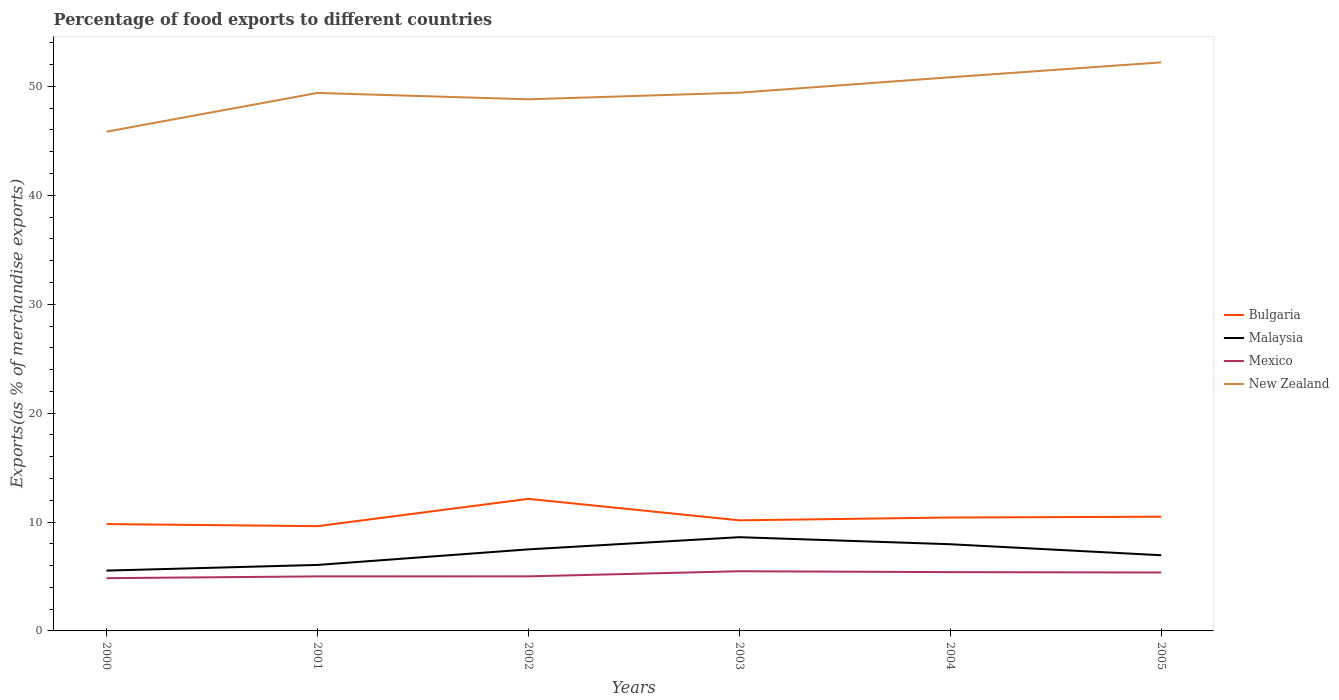How many different coloured lines are there?
Keep it short and to the point. 4. Is the number of lines equal to the number of legend labels?
Make the answer very short. Yes. Across all years, what is the maximum percentage of exports to different countries in Bulgaria?
Provide a succinct answer. 9.62. In which year was the percentage of exports to different countries in Malaysia maximum?
Give a very brief answer. 2000. What is the total percentage of exports to different countries in Mexico in the graph?
Make the answer very short. -0.47. What is the difference between the highest and the second highest percentage of exports to different countries in New Zealand?
Give a very brief answer. 6.37. Is the percentage of exports to different countries in Malaysia strictly greater than the percentage of exports to different countries in Mexico over the years?
Give a very brief answer. No. How many lines are there?
Your answer should be compact. 4. How many years are there in the graph?
Offer a very short reply. 6. Are the values on the major ticks of Y-axis written in scientific E-notation?
Offer a very short reply. No. Does the graph contain any zero values?
Your answer should be very brief. No. Does the graph contain grids?
Your answer should be very brief. No. Where does the legend appear in the graph?
Ensure brevity in your answer.  Center right. How are the legend labels stacked?
Make the answer very short. Vertical. What is the title of the graph?
Offer a terse response. Percentage of food exports to different countries. What is the label or title of the X-axis?
Make the answer very short. Years. What is the label or title of the Y-axis?
Ensure brevity in your answer.  Exports(as % of merchandise exports). What is the Exports(as % of merchandise exports) in Bulgaria in 2000?
Provide a short and direct response. 9.81. What is the Exports(as % of merchandise exports) of Malaysia in 2000?
Your response must be concise. 5.54. What is the Exports(as % of merchandise exports) of Mexico in 2000?
Your response must be concise. 4.84. What is the Exports(as % of merchandise exports) in New Zealand in 2000?
Your answer should be compact. 45.84. What is the Exports(as % of merchandise exports) of Bulgaria in 2001?
Ensure brevity in your answer.  9.62. What is the Exports(as % of merchandise exports) in Malaysia in 2001?
Provide a short and direct response. 6.06. What is the Exports(as % of merchandise exports) of Mexico in 2001?
Keep it short and to the point. 5.01. What is the Exports(as % of merchandise exports) in New Zealand in 2001?
Your answer should be very brief. 49.4. What is the Exports(as % of merchandise exports) of Bulgaria in 2002?
Provide a succinct answer. 12.13. What is the Exports(as % of merchandise exports) in Malaysia in 2002?
Provide a short and direct response. 7.49. What is the Exports(as % of merchandise exports) of Mexico in 2002?
Make the answer very short. 5.01. What is the Exports(as % of merchandise exports) in New Zealand in 2002?
Provide a succinct answer. 48.82. What is the Exports(as % of merchandise exports) of Bulgaria in 2003?
Your response must be concise. 10.16. What is the Exports(as % of merchandise exports) of Malaysia in 2003?
Your answer should be compact. 8.61. What is the Exports(as % of merchandise exports) in Mexico in 2003?
Offer a very short reply. 5.48. What is the Exports(as % of merchandise exports) of New Zealand in 2003?
Your answer should be very brief. 49.42. What is the Exports(as % of merchandise exports) of Bulgaria in 2004?
Offer a terse response. 10.41. What is the Exports(as % of merchandise exports) of Malaysia in 2004?
Provide a short and direct response. 7.96. What is the Exports(as % of merchandise exports) of Mexico in 2004?
Keep it short and to the point. 5.4. What is the Exports(as % of merchandise exports) of New Zealand in 2004?
Your response must be concise. 50.84. What is the Exports(as % of merchandise exports) of Bulgaria in 2005?
Your answer should be compact. 10.49. What is the Exports(as % of merchandise exports) of Malaysia in 2005?
Keep it short and to the point. 6.95. What is the Exports(as % of merchandise exports) of Mexico in 2005?
Your response must be concise. 5.37. What is the Exports(as % of merchandise exports) in New Zealand in 2005?
Provide a short and direct response. 52.21. Across all years, what is the maximum Exports(as % of merchandise exports) of Bulgaria?
Your answer should be very brief. 12.13. Across all years, what is the maximum Exports(as % of merchandise exports) of Malaysia?
Offer a terse response. 8.61. Across all years, what is the maximum Exports(as % of merchandise exports) of Mexico?
Offer a terse response. 5.48. Across all years, what is the maximum Exports(as % of merchandise exports) in New Zealand?
Provide a short and direct response. 52.21. Across all years, what is the minimum Exports(as % of merchandise exports) in Bulgaria?
Your answer should be compact. 9.62. Across all years, what is the minimum Exports(as % of merchandise exports) in Malaysia?
Your answer should be very brief. 5.54. Across all years, what is the minimum Exports(as % of merchandise exports) in Mexico?
Ensure brevity in your answer.  4.84. Across all years, what is the minimum Exports(as % of merchandise exports) of New Zealand?
Your response must be concise. 45.84. What is the total Exports(as % of merchandise exports) in Bulgaria in the graph?
Provide a short and direct response. 62.62. What is the total Exports(as % of merchandise exports) in Malaysia in the graph?
Offer a very short reply. 42.61. What is the total Exports(as % of merchandise exports) of Mexico in the graph?
Keep it short and to the point. 31.1. What is the total Exports(as % of merchandise exports) in New Zealand in the graph?
Ensure brevity in your answer.  296.54. What is the difference between the Exports(as % of merchandise exports) of Bulgaria in 2000 and that in 2001?
Offer a very short reply. 0.19. What is the difference between the Exports(as % of merchandise exports) of Malaysia in 2000 and that in 2001?
Ensure brevity in your answer.  -0.52. What is the difference between the Exports(as % of merchandise exports) in Mexico in 2000 and that in 2001?
Your answer should be compact. -0.16. What is the difference between the Exports(as % of merchandise exports) in New Zealand in 2000 and that in 2001?
Ensure brevity in your answer.  -3.56. What is the difference between the Exports(as % of merchandise exports) of Bulgaria in 2000 and that in 2002?
Ensure brevity in your answer.  -2.32. What is the difference between the Exports(as % of merchandise exports) of Malaysia in 2000 and that in 2002?
Offer a very short reply. -1.95. What is the difference between the Exports(as % of merchandise exports) of Mexico in 2000 and that in 2002?
Provide a succinct answer. -0.17. What is the difference between the Exports(as % of merchandise exports) in New Zealand in 2000 and that in 2002?
Provide a succinct answer. -2.98. What is the difference between the Exports(as % of merchandise exports) of Bulgaria in 2000 and that in 2003?
Keep it short and to the point. -0.34. What is the difference between the Exports(as % of merchandise exports) of Malaysia in 2000 and that in 2003?
Your response must be concise. -3.07. What is the difference between the Exports(as % of merchandise exports) of Mexico in 2000 and that in 2003?
Offer a terse response. -0.64. What is the difference between the Exports(as % of merchandise exports) of New Zealand in 2000 and that in 2003?
Give a very brief answer. -3.58. What is the difference between the Exports(as % of merchandise exports) of Bulgaria in 2000 and that in 2004?
Offer a very short reply. -0.6. What is the difference between the Exports(as % of merchandise exports) of Malaysia in 2000 and that in 2004?
Offer a very short reply. -2.42. What is the difference between the Exports(as % of merchandise exports) in Mexico in 2000 and that in 2004?
Offer a very short reply. -0.56. What is the difference between the Exports(as % of merchandise exports) in New Zealand in 2000 and that in 2004?
Your answer should be very brief. -5. What is the difference between the Exports(as % of merchandise exports) in Bulgaria in 2000 and that in 2005?
Provide a succinct answer. -0.68. What is the difference between the Exports(as % of merchandise exports) in Malaysia in 2000 and that in 2005?
Your answer should be compact. -1.41. What is the difference between the Exports(as % of merchandise exports) of Mexico in 2000 and that in 2005?
Give a very brief answer. -0.52. What is the difference between the Exports(as % of merchandise exports) in New Zealand in 2000 and that in 2005?
Provide a short and direct response. -6.37. What is the difference between the Exports(as % of merchandise exports) of Bulgaria in 2001 and that in 2002?
Provide a short and direct response. -2.51. What is the difference between the Exports(as % of merchandise exports) of Malaysia in 2001 and that in 2002?
Keep it short and to the point. -1.43. What is the difference between the Exports(as % of merchandise exports) of Mexico in 2001 and that in 2002?
Offer a terse response. -0. What is the difference between the Exports(as % of merchandise exports) of New Zealand in 2001 and that in 2002?
Give a very brief answer. 0.58. What is the difference between the Exports(as % of merchandise exports) of Bulgaria in 2001 and that in 2003?
Give a very brief answer. -0.53. What is the difference between the Exports(as % of merchandise exports) in Malaysia in 2001 and that in 2003?
Make the answer very short. -2.55. What is the difference between the Exports(as % of merchandise exports) in Mexico in 2001 and that in 2003?
Your answer should be compact. -0.47. What is the difference between the Exports(as % of merchandise exports) of New Zealand in 2001 and that in 2003?
Provide a short and direct response. -0.02. What is the difference between the Exports(as % of merchandise exports) in Bulgaria in 2001 and that in 2004?
Make the answer very short. -0.79. What is the difference between the Exports(as % of merchandise exports) in Malaysia in 2001 and that in 2004?
Your answer should be very brief. -1.9. What is the difference between the Exports(as % of merchandise exports) in Mexico in 2001 and that in 2004?
Your answer should be compact. -0.39. What is the difference between the Exports(as % of merchandise exports) in New Zealand in 2001 and that in 2004?
Your answer should be compact. -1.44. What is the difference between the Exports(as % of merchandise exports) of Bulgaria in 2001 and that in 2005?
Your answer should be compact. -0.87. What is the difference between the Exports(as % of merchandise exports) in Malaysia in 2001 and that in 2005?
Your response must be concise. -0.89. What is the difference between the Exports(as % of merchandise exports) of Mexico in 2001 and that in 2005?
Ensure brevity in your answer.  -0.36. What is the difference between the Exports(as % of merchandise exports) of New Zealand in 2001 and that in 2005?
Ensure brevity in your answer.  -2.81. What is the difference between the Exports(as % of merchandise exports) of Bulgaria in 2002 and that in 2003?
Provide a succinct answer. 1.97. What is the difference between the Exports(as % of merchandise exports) in Malaysia in 2002 and that in 2003?
Your response must be concise. -1.12. What is the difference between the Exports(as % of merchandise exports) of Mexico in 2002 and that in 2003?
Offer a very short reply. -0.47. What is the difference between the Exports(as % of merchandise exports) in New Zealand in 2002 and that in 2003?
Offer a terse response. -0.61. What is the difference between the Exports(as % of merchandise exports) in Bulgaria in 2002 and that in 2004?
Offer a terse response. 1.71. What is the difference between the Exports(as % of merchandise exports) in Malaysia in 2002 and that in 2004?
Your answer should be compact. -0.47. What is the difference between the Exports(as % of merchandise exports) in Mexico in 2002 and that in 2004?
Ensure brevity in your answer.  -0.39. What is the difference between the Exports(as % of merchandise exports) in New Zealand in 2002 and that in 2004?
Your answer should be compact. -2.02. What is the difference between the Exports(as % of merchandise exports) of Bulgaria in 2002 and that in 2005?
Make the answer very short. 1.64. What is the difference between the Exports(as % of merchandise exports) of Malaysia in 2002 and that in 2005?
Ensure brevity in your answer.  0.54. What is the difference between the Exports(as % of merchandise exports) of Mexico in 2002 and that in 2005?
Ensure brevity in your answer.  -0.36. What is the difference between the Exports(as % of merchandise exports) of New Zealand in 2002 and that in 2005?
Offer a very short reply. -3.39. What is the difference between the Exports(as % of merchandise exports) of Bulgaria in 2003 and that in 2004?
Make the answer very short. -0.26. What is the difference between the Exports(as % of merchandise exports) of Malaysia in 2003 and that in 2004?
Your answer should be compact. 0.65. What is the difference between the Exports(as % of merchandise exports) in Mexico in 2003 and that in 2004?
Your response must be concise. 0.08. What is the difference between the Exports(as % of merchandise exports) of New Zealand in 2003 and that in 2004?
Offer a very short reply. -1.42. What is the difference between the Exports(as % of merchandise exports) of Bulgaria in 2003 and that in 2005?
Your answer should be very brief. -0.33. What is the difference between the Exports(as % of merchandise exports) of Malaysia in 2003 and that in 2005?
Keep it short and to the point. 1.66. What is the difference between the Exports(as % of merchandise exports) in Mexico in 2003 and that in 2005?
Provide a succinct answer. 0.11. What is the difference between the Exports(as % of merchandise exports) of New Zealand in 2003 and that in 2005?
Make the answer very short. -2.79. What is the difference between the Exports(as % of merchandise exports) in Bulgaria in 2004 and that in 2005?
Provide a short and direct response. -0.07. What is the difference between the Exports(as % of merchandise exports) in Malaysia in 2004 and that in 2005?
Offer a very short reply. 1.01. What is the difference between the Exports(as % of merchandise exports) of Mexico in 2004 and that in 2005?
Offer a very short reply. 0.03. What is the difference between the Exports(as % of merchandise exports) in New Zealand in 2004 and that in 2005?
Your response must be concise. -1.37. What is the difference between the Exports(as % of merchandise exports) of Bulgaria in 2000 and the Exports(as % of merchandise exports) of Malaysia in 2001?
Your response must be concise. 3.75. What is the difference between the Exports(as % of merchandise exports) in Bulgaria in 2000 and the Exports(as % of merchandise exports) in Mexico in 2001?
Your answer should be very brief. 4.8. What is the difference between the Exports(as % of merchandise exports) in Bulgaria in 2000 and the Exports(as % of merchandise exports) in New Zealand in 2001?
Make the answer very short. -39.59. What is the difference between the Exports(as % of merchandise exports) in Malaysia in 2000 and the Exports(as % of merchandise exports) in Mexico in 2001?
Provide a short and direct response. 0.53. What is the difference between the Exports(as % of merchandise exports) of Malaysia in 2000 and the Exports(as % of merchandise exports) of New Zealand in 2001?
Keep it short and to the point. -43.86. What is the difference between the Exports(as % of merchandise exports) in Mexico in 2000 and the Exports(as % of merchandise exports) in New Zealand in 2001?
Your answer should be compact. -44.56. What is the difference between the Exports(as % of merchandise exports) of Bulgaria in 2000 and the Exports(as % of merchandise exports) of Malaysia in 2002?
Your answer should be very brief. 2.32. What is the difference between the Exports(as % of merchandise exports) of Bulgaria in 2000 and the Exports(as % of merchandise exports) of Mexico in 2002?
Your answer should be compact. 4.8. What is the difference between the Exports(as % of merchandise exports) in Bulgaria in 2000 and the Exports(as % of merchandise exports) in New Zealand in 2002?
Provide a short and direct response. -39.01. What is the difference between the Exports(as % of merchandise exports) in Malaysia in 2000 and the Exports(as % of merchandise exports) in Mexico in 2002?
Offer a terse response. 0.53. What is the difference between the Exports(as % of merchandise exports) of Malaysia in 2000 and the Exports(as % of merchandise exports) of New Zealand in 2002?
Give a very brief answer. -43.28. What is the difference between the Exports(as % of merchandise exports) of Mexico in 2000 and the Exports(as % of merchandise exports) of New Zealand in 2002?
Your answer should be very brief. -43.98. What is the difference between the Exports(as % of merchandise exports) in Bulgaria in 2000 and the Exports(as % of merchandise exports) in Malaysia in 2003?
Ensure brevity in your answer.  1.2. What is the difference between the Exports(as % of merchandise exports) in Bulgaria in 2000 and the Exports(as % of merchandise exports) in Mexico in 2003?
Your response must be concise. 4.33. What is the difference between the Exports(as % of merchandise exports) of Bulgaria in 2000 and the Exports(as % of merchandise exports) of New Zealand in 2003?
Offer a terse response. -39.61. What is the difference between the Exports(as % of merchandise exports) in Malaysia in 2000 and the Exports(as % of merchandise exports) in Mexico in 2003?
Your response must be concise. 0.06. What is the difference between the Exports(as % of merchandise exports) in Malaysia in 2000 and the Exports(as % of merchandise exports) in New Zealand in 2003?
Ensure brevity in your answer.  -43.88. What is the difference between the Exports(as % of merchandise exports) of Mexico in 2000 and the Exports(as % of merchandise exports) of New Zealand in 2003?
Your answer should be very brief. -44.58. What is the difference between the Exports(as % of merchandise exports) of Bulgaria in 2000 and the Exports(as % of merchandise exports) of Malaysia in 2004?
Keep it short and to the point. 1.85. What is the difference between the Exports(as % of merchandise exports) in Bulgaria in 2000 and the Exports(as % of merchandise exports) in Mexico in 2004?
Keep it short and to the point. 4.41. What is the difference between the Exports(as % of merchandise exports) of Bulgaria in 2000 and the Exports(as % of merchandise exports) of New Zealand in 2004?
Keep it short and to the point. -41.03. What is the difference between the Exports(as % of merchandise exports) in Malaysia in 2000 and the Exports(as % of merchandise exports) in Mexico in 2004?
Offer a very short reply. 0.14. What is the difference between the Exports(as % of merchandise exports) of Malaysia in 2000 and the Exports(as % of merchandise exports) of New Zealand in 2004?
Provide a short and direct response. -45.3. What is the difference between the Exports(as % of merchandise exports) in Mexico in 2000 and the Exports(as % of merchandise exports) in New Zealand in 2004?
Make the answer very short. -46. What is the difference between the Exports(as % of merchandise exports) in Bulgaria in 2000 and the Exports(as % of merchandise exports) in Malaysia in 2005?
Ensure brevity in your answer.  2.86. What is the difference between the Exports(as % of merchandise exports) of Bulgaria in 2000 and the Exports(as % of merchandise exports) of Mexico in 2005?
Offer a terse response. 4.45. What is the difference between the Exports(as % of merchandise exports) in Bulgaria in 2000 and the Exports(as % of merchandise exports) in New Zealand in 2005?
Keep it short and to the point. -42.4. What is the difference between the Exports(as % of merchandise exports) in Malaysia in 2000 and the Exports(as % of merchandise exports) in Mexico in 2005?
Ensure brevity in your answer.  0.18. What is the difference between the Exports(as % of merchandise exports) in Malaysia in 2000 and the Exports(as % of merchandise exports) in New Zealand in 2005?
Offer a terse response. -46.67. What is the difference between the Exports(as % of merchandise exports) of Mexico in 2000 and the Exports(as % of merchandise exports) of New Zealand in 2005?
Make the answer very short. -47.37. What is the difference between the Exports(as % of merchandise exports) of Bulgaria in 2001 and the Exports(as % of merchandise exports) of Malaysia in 2002?
Provide a short and direct response. 2.13. What is the difference between the Exports(as % of merchandise exports) of Bulgaria in 2001 and the Exports(as % of merchandise exports) of Mexico in 2002?
Keep it short and to the point. 4.61. What is the difference between the Exports(as % of merchandise exports) in Bulgaria in 2001 and the Exports(as % of merchandise exports) in New Zealand in 2002?
Offer a very short reply. -39.2. What is the difference between the Exports(as % of merchandise exports) of Malaysia in 2001 and the Exports(as % of merchandise exports) of Mexico in 2002?
Your response must be concise. 1.05. What is the difference between the Exports(as % of merchandise exports) in Malaysia in 2001 and the Exports(as % of merchandise exports) in New Zealand in 2002?
Offer a terse response. -42.76. What is the difference between the Exports(as % of merchandise exports) of Mexico in 2001 and the Exports(as % of merchandise exports) of New Zealand in 2002?
Provide a short and direct response. -43.81. What is the difference between the Exports(as % of merchandise exports) of Bulgaria in 2001 and the Exports(as % of merchandise exports) of Malaysia in 2003?
Provide a succinct answer. 1.01. What is the difference between the Exports(as % of merchandise exports) in Bulgaria in 2001 and the Exports(as % of merchandise exports) in Mexico in 2003?
Provide a succinct answer. 4.14. What is the difference between the Exports(as % of merchandise exports) of Bulgaria in 2001 and the Exports(as % of merchandise exports) of New Zealand in 2003?
Make the answer very short. -39.8. What is the difference between the Exports(as % of merchandise exports) of Malaysia in 2001 and the Exports(as % of merchandise exports) of Mexico in 2003?
Make the answer very short. 0.58. What is the difference between the Exports(as % of merchandise exports) of Malaysia in 2001 and the Exports(as % of merchandise exports) of New Zealand in 2003?
Make the answer very short. -43.37. What is the difference between the Exports(as % of merchandise exports) in Mexico in 2001 and the Exports(as % of merchandise exports) in New Zealand in 2003?
Your answer should be compact. -44.42. What is the difference between the Exports(as % of merchandise exports) of Bulgaria in 2001 and the Exports(as % of merchandise exports) of Malaysia in 2004?
Offer a very short reply. 1.66. What is the difference between the Exports(as % of merchandise exports) of Bulgaria in 2001 and the Exports(as % of merchandise exports) of Mexico in 2004?
Ensure brevity in your answer.  4.22. What is the difference between the Exports(as % of merchandise exports) of Bulgaria in 2001 and the Exports(as % of merchandise exports) of New Zealand in 2004?
Your answer should be compact. -41.22. What is the difference between the Exports(as % of merchandise exports) in Malaysia in 2001 and the Exports(as % of merchandise exports) in Mexico in 2004?
Offer a very short reply. 0.66. What is the difference between the Exports(as % of merchandise exports) in Malaysia in 2001 and the Exports(as % of merchandise exports) in New Zealand in 2004?
Your response must be concise. -44.78. What is the difference between the Exports(as % of merchandise exports) in Mexico in 2001 and the Exports(as % of merchandise exports) in New Zealand in 2004?
Your response must be concise. -45.83. What is the difference between the Exports(as % of merchandise exports) in Bulgaria in 2001 and the Exports(as % of merchandise exports) in Malaysia in 2005?
Give a very brief answer. 2.67. What is the difference between the Exports(as % of merchandise exports) in Bulgaria in 2001 and the Exports(as % of merchandise exports) in Mexico in 2005?
Offer a very short reply. 4.26. What is the difference between the Exports(as % of merchandise exports) of Bulgaria in 2001 and the Exports(as % of merchandise exports) of New Zealand in 2005?
Your response must be concise. -42.59. What is the difference between the Exports(as % of merchandise exports) of Malaysia in 2001 and the Exports(as % of merchandise exports) of Mexico in 2005?
Keep it short and to the point. 0.69. What is the difference between the Exports(as % of merchandise exports) of Malaysia in 2001 and the Exports(as % of merchandise exports) of New Zealand in 2005?
Give a very brief answer. -46.15. What is the difference between the Exports(as % of merchandise exports) of Mexico in 2001 and the Exports(as % of merchandise exports) of New Zealand in 2005?
Offer a terse response. -47.2. What is the difference between the Exports(as % of merchandise exports) in Bulgaria in 2002 and the Exports(as % of merchandise exports) in Malaysia in 2003?
Ensure brevity in your answer.  3.52. What is the difference between the Exports(as % of merchandise exports) of Bulgaria in 2002 and the Exports(as % of merchandise exports) of Mexico in 2003?
Make the answer very short. 6.65. What is the difference between the Exports(as % of merchandise exports) in Bulgaria in 2002 and the Exports(as % of merchandise exports) in New Zealand in 2003?
Provide a succinct answer. -37.3. What is the difference between the Exports(as % of merchandise exports) of Malaysia in 2002 and the Exports(as % of merchandise exports) of Mexico in 2003?
Offer a very short reply. 2.01. What is the difference between the Exports(as % of merchandise exports) in Malaysia in 2002 and the Exports(as % of merchandise exports) in New Zealand in 2003?
Your answer should be very brief. -41.94. What is the difference between the Exports(as % of merchandise exports) in Mexico in 2002 and the Exports(as % of merchandise exports) in New Zealand in 2003?
Make the answer very short. -44.41. What is the difference between the Exports(as % of merchandise exports) in Bulgaria in 2002 and the Exports(as % of merchandise exports) in Malaysia in 2004?
Your response must be concise. 4.17. What is the difference between the Exports(as % of merchandise exports) in Bulgaria in 2002 and the Exports(as % of merchandise exports) in Mexico in 2004?
Provide a succinct answer. 6.73. What is the difference between the Exports(as % of merchandise exports) in Bulgaria in 2002 and the Exports(as % of merchandise exports) in New Zealand in 2004?
Your answer should be compact. -38.71. What is the difference between the Exports(as % of merchandise exports) of Malaysia in 2002 and the Exports(as % of merchandise exports) of Mexico in 2004?
Offer a very short reply. 2.09. What is the difference between the Exports(as % of merchandise exports) in Malaysia in 2002 and the Exports(as % of merchandise exports) in New Zealand in 2004?
Your answer should be very brief. -43.35. What is the difference between the Exports(as % of merchandise exports) in Mexico in 2002 and the Exports(as % of merchandise exports) in New Zealand in 2004?
Make the answer very short. -45.83. What is the difference between the Exports(as % of merchandise exports) in Bulgaria in 2002 and the Exports(as % of merchandise exports) in Malaysia in 2005?
Provide a short and direct response. 5.18. What is the difference between the Exports(as % of merchandise exports) in Bulgaria in 2002 and the Exports(as % of merchandise exports) in Mexico in 2005?
Your answer should be very brief. 6.76. What is the difference between the Exports(as % of merchandise exports) of Bulgaria in 2002 and the Exports(as % of merchandise exports) of New Zealand in 2005?
Ensure brevity in your answer.  -40.08. What is the difference between the Exports(as % of merchandise exports) in Malaysia in 2002 and the Exports(as % of merchandise exports) in Mexico in 2005?
Offer a very short reply. 2.12. What is the difference between the Exports(as % of merchandise exports) in Malaysia in 2002 and the Exports(as % of merchandise exports) in New Zealand in 2005?
Offer a very short reply. -44.72. What is the difference between the Exports(as % of merchandise exports) in Mexico in 2002 and the Exports(as % of merchandise exports) in New Zealand in 2005?
Provide a short and direct response. -47.2. What is the difference between the Exports(as % of merchandise exports) in Bulgaria in 2003 and the Exports(as % of merchandise exports) in Malaysia in 2004?
Your answer should be compact. 2.19. What is the difference between the Exports(as % of merchandise exports) in Bulgaria in 2003 and the Exports(as % of merchandise exports) in Mexico in 2004?
Ensure brevity in your answer.  4.76. What is the difference between the Exports(as % of merchandise exports) in Bulgaria in 2003 and the Exports(as % of merchandise exports) in New Zealand in 2004?
Provide a succinct answer. -40.69. What is the difference between the Exports(as % of merchandise exports) in Malaysia in 2003 and the Exports(as % of merchandise exports) in Mexico in 2004?
Give a very brief answer. 3.21. What is the difference between the Exports(as % of merchandise exports) of Malaysia in 2003 and the Exports(as % of merchandise exports) of New Zealand in 2004?
Your answer should be very brief. -42.23. What is the difference between the Exports(as % of merchandise exports) of Mexico in 2003 and the Exports(as % of merchandise exports) of New Zealand in 2004?
Ensure brevity in your answer.  -45.36. What is the difference between the Exports(as % of merchandise exports) in Bulgaria in 2003 and the Exports(as % of merchandise exports) in Malaysia in 2005?
Your response must be concise. 3.21. What is the difference between the Exports(as % of merchandise exports) of Bulgaria in 2003 and the Exports(as % of merchandise exports) of Mexico in 2005?
Offer a terse response. 4.79. What is the difference between the Exports(as % of merchandise exports) in Bulgaria in 2003 and the Exports(as % of merchandise exports) in New Zealand in 2005?
Offer a very short reply. -42.05. What is the difference between the Exports(as % of merchandise exports) of Malaysia in 2003 and the Exports(as % of merchandise exports) of Mexico in 2005?
Ensure brevity in your answer.  3.24. What is the difference between the Exports(as % of merchandise exports) in Malaysia in 2003 and the Exports(as % of merchandise exports) in New Zealand in 2005?
Provide a succinct answer. -43.6. What is the difference between the Exports(as % of merchandise exports) of Mexico in 2003 and the Exports(as % of merchandise exports) of New Zealand in 2005?
Give a very brief answer. -46.73. What is the difference between the Exports(as % of merchandise exports) in Bulgaria in 2004 and the Exports(as % of merchandise exports) in Malaysia in 2005?
Keep it short and to the point. 3.46. What is the difference between the Exports(as % of merchandise exports) in Bulgaria in 2004 and the Exports(as % of merchandise exports) in Mexico in 2005?
Offer a very short reply. 5.05. What is the difference between the Exports(as % of merchandise exports) in Bulgaria in 2004 and the Exports(as % of merchandise exports) in New Zealand in 2005?
Ensure brevity in your answer.  -41.8. What is the difference between the Exports(as % of merchandise exports) in Malaysia in 2004 and the Exports(as % of merchandise exports) in Mexico in 2005?
Provide a succinct answer. 2.6. What is the difference between the Exports(as % of merchandise exports) in Malaysia in 2004 and the Exports(as % of merchandise exports) in New Zealand in 2005?
Offer a very short reply. -44.25. What is the difference between the Exports(as % of merchandise exports) of Mexico in 2004 and the Exports(as % of merchandise exports) of New Zealand in 2005?
Your answer should be compact. -46.81. What is the average Exports(as % of merchandise exports) of Bulgaria per year?
Give a very brief answer. 10.44. What is the average Exports(as % of merchandise exports) of Malaysia per year?
Keep it short and to the point. 7.1. What is the average Exports(as % of merchandise exports) of Mexico per year?
Ensure brevity in your answer.  5.18. What is the average Exports(as % of merchandise exports) in New Zealand per year?
Give a very brief answer. 49.42. In the year 2000, what is the difference between the Exports(as % of merchandise exports) of Bulgaria and Exports(as % of merchandise exports) of Malaysia?
Offer a very short reply. 4.27. In the year 2000, what is the difference between the Exports(as % of merchandise exports) of Bulgaria and Exports(as % of merchandise exports) of Mexico?
Give a very brief answer. 4.97. In the year 2000, what is the difference between the Exports(as % of merchandise exports) in Bulgaria and Exports(as % of merchandise exports) in New Zealand?
Your answer should be very brief. -36.03. In the year 2000, what is the difference between the Exports(as % of merchandise exports) in Malaysia and Exports(as % of merchandise exports) in Mexico?
Your answer should be compact. 0.7. In the year 2000, what is the difference between the Exports(as % of merchandise exports) in Malaysia and Exports(as % of merchandise exports) in New Zealand?
Provide a short and direct response. -40.3. In the year 2000, what is the difference between the Exports(as % of merchandise exports) in Mexico and Exports(as % of merchandise exports) in New Zealand?
Offer a very short reply. -41. In the year 2001, what is the difference between the Exports(as % of merchandise exports) of Bulgaria and Exports(as % of merchandise exports) of Malaysia?
Ensure brevity in your answer.  3.56. In the year 2001, what is the difference between the Exports(as % of merchandise exports) of Bulgaria and Exports(as % of merchandise exports) of Mexico?
Keep it short and to the point. 4.61. In the year 2001, what is the difference between the Exports(as % of merchandise exports) in Bulgaria and Exports(as % of merchandise exports) in New Zealand?
Provide a succinct answer. -39.78. In the year 2001, what is the difference between the Exports(as % of merchandise exports) in Malaysia and Exports(as % of merchandise exports) in Mexico?
Offer a terse response. 1.05. In the year 2001, what is the difference between the Exports(as % of merchandise exports) of Malaysia and Exports(as % of merchandise exports) of New Zealand?
Make the answer very short. -43.34. In the year 2001, what is the difference between the Exports(as % of merchandise exports) in Mexico and Exports(as % of merchandise exports) in New Zealand?
Your response must be concise. -44.39. In the year 2002, what is the difference between the Exports(as % of merchandise exports) in Bulgaria and Exports(as % of merchandise exports) in Malaysia?
Offer a terse response. 4.64. In the year 2002, what is the difference between the Exports(as % of merchandise exports) of Bulgaria and Exports(as % of merchandise exports) of Mexico?
Offer a very short reply. 7.12. In the year 2002, what is the difference between the Exports(as % of merchandise exports) in Bulgaria and Exports(as % of merchandise exports) in New Zealand?
Make the answer very short. -36.69. In the year 2002, what is the difference between the Exports(as % of merchandise exports) of Malaysia and Exports(as % of merchandise exports) of Mexico?
Offer a very short reply. 2.48. In the year 2002, what is the difference between the Exports(as % of merchandise exports) of Malaysia and Exports(as % of merchandise exports) of New Zealand?
Provide a short and direct response. -41.33. In the year 2002, what is the difference between the Exports(as % of merchandise exports) of Mexico and Exports(as % of merchandise exports) of New Zealand?
Make the answer very short. -43.81. In the year 2003, what is the difference between the Exports(as % of merchandise exports) in Bulgaria and Exports(as % of merchandise exports) in Malaysia?
Provide a short and direct response. 1.55. In the year 2003, what is the difference between the Exports(as % of merchandise exports) of Bulgaria and Exports(as % of merchandise exports) of Mexico?
Offer a terse response. 4.68. In the year 2003, what is the difference between the Exports(as % of merchandise exports) of Bulgaria and Exports(as % of merchandise exports) of New Zealand?
Provide a short and direct response. -39.27. In the year 2003, what is the difference between the Exports(as % of merchandise exports) in Malaysia and Exports(as % of merchandise exports) in Mexico?
Provide a short and direct response. 3.13. In the year 2003, what is the difference between the Exports(as % of merchandise exports) of Malaysia and Exports(as % of merchandise exports) of New Zealand?
Offer a very short reply. -40.82. In the year 2003, what is the difference between the Exports(as % of merchandise exports) of Mexico and Exports(as % of merchandise exports) of New Zealand?
Your answer should be very brief. -43.95. In the year 2004, what is the difference between the Exports(as % of merchandise exports) in Bulgaria and Exports(as % of merchandise exports) in Malaysia?
Provide a short and direct response. 2.45. In the year 2004, what is the difference between the Exports(as % of merchandise exports) in Bulgaria and Exports(as % of merchandise exports) in Mexico?
Provide a succinct answer. 5.01. In the year 2004, what is the difference between the Exports(as % of merchandise exports) of Bulgaria and Exports(as % of merchandise exports) of New Zealand?
Offer a terse response. -40.43. In the year 2004, what is the difference between the Exports(as % of merchandise exports) of Malaysia and Exports(as % of merchandise exports) of Mexico?
Offer a very short reply. 2.56. In the year 2004, what is the difference between the Exports(as % of merchandise exports) of Malaysia and Exports(as % of merchandise exports) of New Zealand?
Give a very brief answer. -42.88. In the year 2004, what is the difference between the Exports(as % of merchandise exports) of Mexico and Exports(as % of merchandise exports) of New Zealand?
Your answer should be very brief. -45.44. In the year 2005, what is the difference between the Exports(as % of merchandise exports) of Bulgaria and Exports(as % of merchandise exports) of Malaysia?
Your answer should be compact. 3.54. In the year 2005, what is the difference between the Exports(as % of merchandise exports) of Bulgaria and Exports(as % of merchandise exports) of Mexico?
Keep it short and to the point. 5.12. In the year 2005, what is the difference between the Exports(as % of merchandise exports) of Bulgaria and Exports(as % of merchandise exports) of New Zealand?
Offer a terse response. -41.72. In the year 2005, what is the difference between the Exports(as % of merchandise exports) of Malaysia and Exports(as % of merchandise exports) of Mexico?
Provide a succinct answer. 1.58. In the year 2005, what is the difference between the Exports(as % of merchandise exports) in Malaysia and Exports(as % of merchandise exports) in New Zealand?
Your response must be concise. -45.26. In the year 2005, what is the difference between the Exports(as % of merchandise exports) of Mexico and Exports(as % of merchandise exports) of New Zealand?
Provide a succinct answer. -46.84. What is the ratio of the Exports(as % of merchandise exports) of Bulgaria in 2000 to that in 2001?
Offer a very short reply. 1.02. What is the ratio of the Exports(as % of merchandise exports) in Malaysia in 2000 to that in 2001?
Offer a terse response. 0.91. What is the ratio of the Exports(as % of merchandise exports) of Mexico in 2000 to that in 2001?
Provide a succinct answer. 0.97. What is the ratio of the Exports(as % of merchandise exports) in New Zealand in 2000 to that in 2001?
Make the answer very short. 0.93. What is the ratio of the Exports(as % of merchandise exports) in Bulgaria in 2000 to that in 2002?
Your answer should be very brief. 0.81. What is the ratio of the Exports(as % of merchandise exports) in Malaysia in 2000 to that in 2002?
Provide a succinct answer. 0.74. What is the ratio of the Exports(as % of merchandise exports) in Mexico in 2000 to that in 2002?
Give a very brief answer. 0.97. What is the ratio of the Exports(as % of merchandise exports) in New Zealand in 2000 to that in 2002?
Provide a succinct answer. 0.94. What is the ratio of the Exports(as % of merchandise exports) in Bulgaria in 2000 to that in 2003?
Offer a very short reply. 0.97. What is the ratio of the Exports(as % of merchandise exports) of Malaysia in 2000 to that in 2003?
Your answer should be very brief. 0.64. What is the ratio of the Exports(as % of merchandise exports) of Mexico in 2000 to that in 2003?
Give a very brief answer. 0.88. What is the ratio of the Exports(as % of merchandise exports) in New Zealand in 2000 to that in 2003?
Provide a succinct answer. 0.93. What is the ratio of the Exports(as % of merchandise exports) in Bulgaria in 2000 to that in 2004?
Your response must be concise. 0.94. What is the ratio of the Exports(as % of merchandise exports) in Malaysia in 2000 to that in 2004?
Keep it short and to the point. 0.7. What is the ratio of the Exports(as % of merchandise exports) of Mexico in 2000 to that in 2004?
Keep it short and to the point. 0.9. What is the ratio of the Exports(as % of merchandise exports) in New Zealand in 2000 to that in 2004?
Give a very brief answer. 0.9. What is the ratio of the Exports(as % of merchandise exports) of Bulgaria in 2000 to that in 2005?
Your response must be concise. 0.94. What is the ratio of the Exports(as % of merchandise exports) of Malaysia in 2000 to that in 2005?
Provide a short and direct response. 0.8. What is the ratio of the Exports(as % of merchandise exports) in Mexico in 2000 to that in 2005?
Offer a very short reply. 0.9. What is the ratio of the Exports(as % of merchandise exports) of New Zealand in 2000 to that in 2005?
Your response must be concise. 0.88. What is the ratio of the Exports(as % of merchandise exports) of Bulgaria in 2001 to that in 2002?
Your answer should be compact. 0.79. What is the ratio of the Exports(as % of merchandise exports) of Malaysia in 2001 to that in 2002?
Ensure brevity in your answer.  0.81. What is the ratio of the Exports(as % of merchandise exports) of New Zealand in 2001 to that in 2002?
Your answer should be very brief. 1.01. What is the ratio of the Exports(as % of merchandise exports) of Malaysia in 2001 to that in 2003?
Provide a short and direct response. 0.7. What is the ratio of the Exports(as % of merchandise exports) of Mexico in 2001 to that in 2003?
Keep it short and to the point. 0.91. What is the ratio of the Exports(as % of merchandise exports) of Bulgaria in 2001 to that in 2004?
Give a very brief answer. 0.92. What is the ratio of the Exports(as % of merchandise exports) of Malaysia in 2001 to that in 2004?
Make the answer very short. 0.76. What is the ratio of the Exports(as % of merchandise exports) of Mexico in 2001 to that in 2004?
Give a very brief answer. 0.93. What is the ratio of the Exports(as % of merchandise exports) of New Zealand in 2001 to that in 2004?
Your answer should be compact. 0.97. What is the ratio of the Exports(as % of merchandise exports) of Bulgaria in 2001 to that in 2005?
Give a very brief answer. 0.92. What is the ratio of the Exports(as % of merchandise exports) in Malaysia in 2001 to that in 2005?
Provide a succinct answer. 0.87. What is the ratio of the Exports(as % of merchandise exports) in New Zealand in 2001 to that in 2005?
Keep it short and to the point. 0.95. What is the ratio of the Exports(as % of merchandise exports) in Bulgaria in 2002 to that in 2003?
Offer a terse response. 1.19. What is the ratio of the Exports(as % of merchandise exports) in Malaysia in 2002 to that in 2003?
Your response must be concise. 0.87. What is the ratio of the Exports(as % of merchandise exports) of Mexico in 2002 to that in 2003?
Your answer should be very brief. 0.91. What is the ratio of the Exports(as % of merchandise exports) in New Zealand in 2002 to that in 2003?
Offer a terse response. 0.99. What is the ratio of the Exports(as % of merchandise exports) of Bulgaria in 2002 to that in 2004?
Your response must be concise. 1.16. What is the ratio of the Exports(as % of merchandise exports) of Malaysia in 2002 to that in 2004?
Keep it short and to the point. 0.94. What is the ratio of the Exports(as % of merchandise exports) in Mexico in 2002 to that in 2004?
Provide a succinct answer. 0.93. What is the ratio of the Exports(as % of merchandise exports) of New Zealand in 2002 to that in 2004?
Keep it short and to the point. 0.96. What is the ratio of the Exports(as % of merchandise exports) in Bulgaria in 2002 to that in 2005?
Your answer should be very brief. 1.16. What is the ratio of the Exports(as % of merchandise exports) of Malaysia in 2002 to that in 2005?
Provide a short and direct response. 1.08. What is the ratio of the Exports(as % of merchandise exports) in Mexico in 2002 to that in 2005?
Make the answer very short. 0.93. What is the ratio of the Exports(as % of merchandise exports) of New Zealand in 2002 to that in 2005?
Offer a terse response. 0.94. What is the ratio of the Exports(as % of merchandise exports) of Bulgaria in 2003 to that in 2004?
Keep it short and to the point. 0.98. What is the ratio of the Exports(as % of merchandise exports) of Malaysia in 2003 to that in 2004?
Keep it short and to the point. 1.08. What is the ratio of the Exports(as % of merchandise exports) of Mexico in 2003 to that in 2004?
Your answer should be very brief. 1.01. What is the ratio of the Exports(as % of merchandise exports) in New Zealand in 2003 to that in 2004?
Ensure brevity in your answer.  0.97. What is the ratio of the Exports(as % of merchandise exports) of Bulgaria in 2003 to that in 2005?
Offer a terse response. 0.97. What is the ratio of the Exports(as % of merchandise exports) in Malaysia in 2003 to that in 2005?
Give a very brief answer. 1.24. What is the ratio of the Exports(as % of merchandise exports) in Mexico in 2003 to that in 2005?
Offer a very short reply. 1.02. What is the ratio of the Exports(as % of merchandise exports) in New Zealand in 2003 to that in 2005?
Offer a very short reply. 0.95. What is the ratio of the Exports(as % of merchandise exports) of Malaysia in 2004 to that in 2005?
Your answer should be compact. 1.15. What is the ratio of the Exports(as % of merchandise exports) in Mexico in 2004 to that in 2005?
Offer a very short reply. 1.01. What is the ratio of the Exports(as % of merchandise exports) of New Zealand in 2004 to that in 2005?
Your answer should be very brief. 0.97. What is the difference between the highest and the second highest Exports(as % of merchandise exports) in Bulgaria?
Make the answer very short. 1.64. What is the difference between the highest and the second highest Exports(as % of merchandise exports) in Malaysia?
Your answer should be compact. 0.65. What is the difference between the highest and the second highest Exports(as % of merchandise exports) of Mexico?
Provide a short and direct response. 0.08. What is the difference between the highest and the second highest Exports(as % of merchandise exports) of New Zealand?
Offer a very short reply. 1.37. What is the difference between the highest and the lowest Exports(as % of merchandise exports) of Bulgaria?
Give a very brief answer. 2.51. What is the difference between the highest and the lowest Exports(as % of merchandise exports) of Malaysia?
Provide a short and direct response. 3.07. What is the difference between the highest and the lowest Exports(as % of merchandise exports) in Mexico?
Provide a short and direct response. 0.64. What is the difference between the highest and the lowest Exports(as % of merchandise exports) in New Zealand?
Your response must be concise. 6.37. 